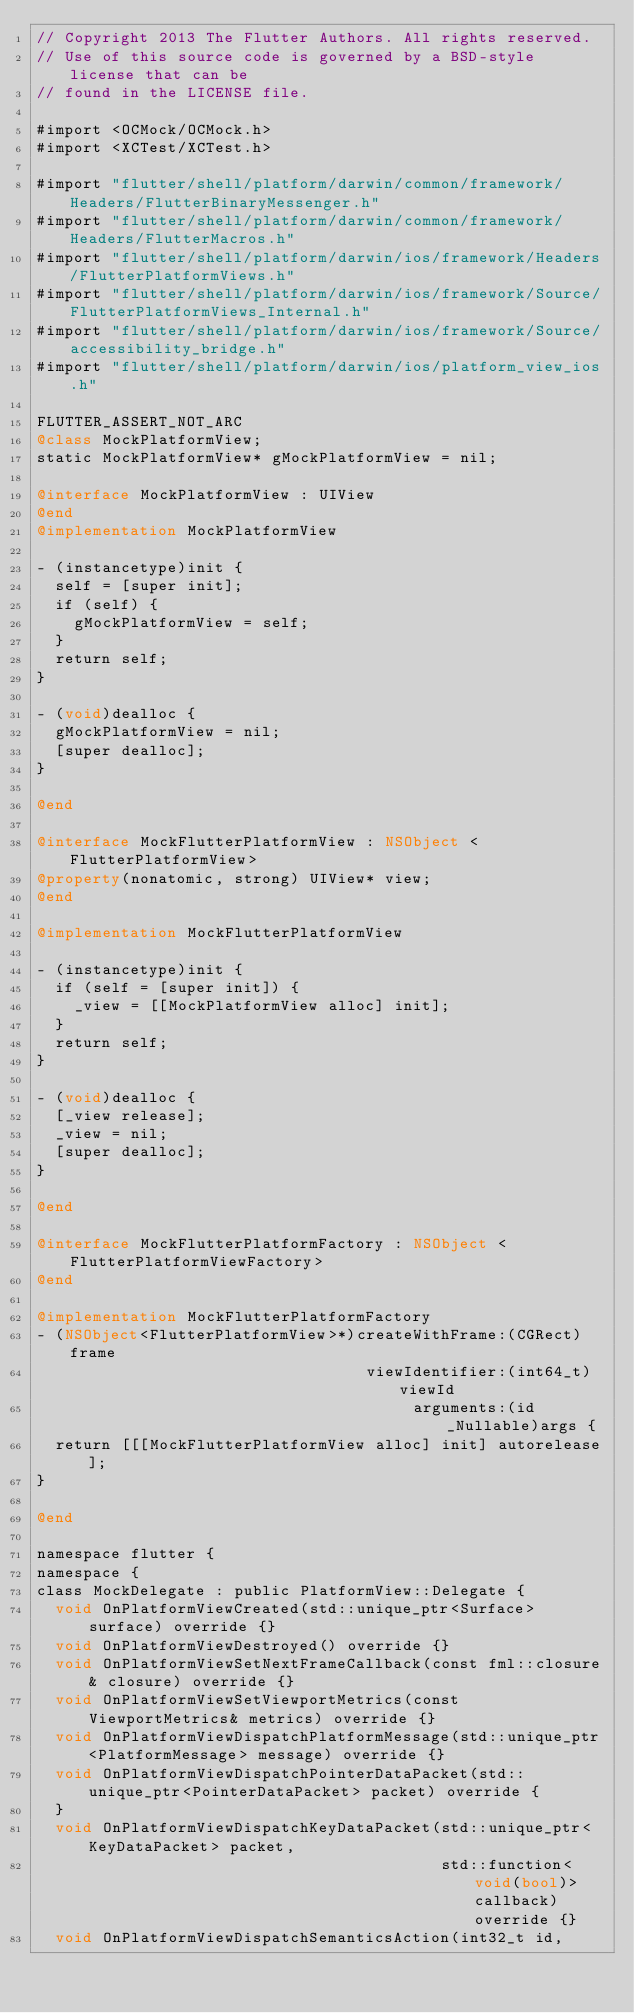<code> <loc_0><loc_0><loc_500><loc_500><_ObjectiveC_>// Copyright 2013 The Flutter Authors. All rights reserved.
// Use of this source code is governed by a BSD-style license that can be
// found in the LICENSE file.

#import <OCMock/OCMock.h>
#import <XCTest/XCTest.h>

#import "flutter/shell/platform/darwin/common/framework/Headers/FlutterBinaryMessenger.h"
#import "flutter/shell/platform/darwin/common/framework/Headers/FlutterMacros.h"
#import "flutter/shell/platform/darwin/ios/framework/Headers/FlutterPlatformViews.h"
#import "flutter/shell/platform/darwin/ios/framework/Source/FlutterPlatformViews_Internal.h"
#import "flutter/shell/platform/darwin/ios/framework/Source/accessibility_bridge.h"
#import "flutter/shell/platform/darwin/ios/platform_view_ios.h"

FLUTTER_ASSERT_NOT_ARC
@class MockPlatformView;
static MockPlatformView* gMockPlatformView = nil;

@interface MockPlatformView : UIView
@end
@implementation MockPlatformView

- (instancetype)init {
  self = [super init];
  if (self) {
    gMockPlatformView = self;
  }
  return self;
}

- (void)dealloc {
  gMockPlatformView = nil;
  [super dealloc];
}

@end

@interface MockFlutterPlatformView : NSObject <FlutterPlatformView>
@property(nonatomic, strong) UIView* view;
@end

@implementation MockFlutterPlatformView

- (instancetype)init {
  if (self = [super init]) {
    _view = [[MockPlatformView alloc] init];
  }
  return self;
}

- (void)dealloc {
  [_view release];
  _view = nil;
  [super dealloc];
}

@end

@interface MockFlutterPlatformFactory : NSObject <FlutterPlatformViewFactory>
@end

@implementation MockFlutterPlatformFactory
- (NSObject<FlutterPlatformView>*)createWithFrame:(CGRect)frame
                                   viewIdentifier:(int64_t)viewId
                                        arguments:(id _Nullable)args {
  return [[[MockFlutterPlatformView alloc] init] autorelease];
}

@end

namespace flutter {
namespace {
class MockDelegate : public PlatformView::Delegate {
  void OnPlatformViewCreated(std::unique_ptr<Surface> surface) override {}
  void OnPlatformViewDestroyed() override {}
  void OnPlatformViewSetNextFrameCallback(const fml::closure& closure) override {}
  void OnPlatformViewSetViewportMetrics(const ViewportMetrics& metrics) override {}
  void OnPlatformViewDispatchPlatformMessage(std::unique_ptr<PlatformMessage> message) override {}
  void OnPlatformViewDispatchPointerDataPacket(std::unique_ptr<PointerDataPacket> packet) override {
  }
  void OnPlatformViewDispatchKeyDataPacket(std::unique_ptr<KeyDataPacket> packet,
                                           std::function<void(bool)> callback) override {}
  void OnPlatformViewDispatchSemanticsAction(int32_t id,</code> 